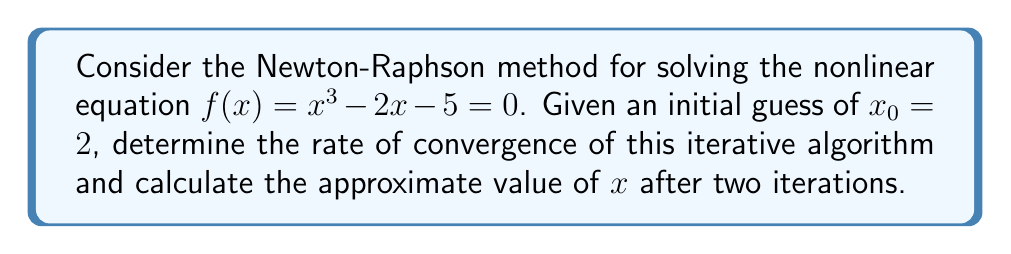What is the answer to this math problem? 1) The Newton-Raphson method is given by the iterative formula:

   $$x_{n+1} = x_n - \frac{f(x_n)}{f'(x_n)}$$

2) For our function $f(x) = x^3 - 2x - 5$, we need to calculate $f'(x)$:
   
   $$f'(x) = 3x^2 - 2$$

3) Now, let's perform the iterations:

   For $n = 0$:
   $$x_1 = 2 - \frac{f(2)}{f'(2)} = 2 - \frac{2^3 - 2(2) - 5}{3(2)^2 - 2} = 2 - \frac{-1}{10} = 2.1$$

   For $n = 1$:
   $$x_2 = 2.1 - \frac{f(2.1)}{f'(2.1)} = 2.1 - \frac{2.1^3 - 2(2.1) - 5}{3(2.1)^2 - 2} \approx 2.0946$$

4) To determine the rate of convergence, we need to look at the error term:

   $$|e_{n+1}| \approx C|e_n|^p$$

   where $C$ is a constant and $p$ is the order of convergence.

5) For the Newton-Raphson method, it's known that $p = 2$ (quadratic convergence) if $f'(x) \neq 0$ near the root and $f''(x)$ is continuous.

6) We can verify this by calculating:

   $$\frac{|x_2 - x^*|}{|x_1 - x^*|^2}$$

   where $x^*$ is the true root. We don't know $x^*$ exactly, but we can approximate it with $x_2$.

7) This ratio should be approximately constant if the convergence is indeed quadratic.
Answer: Quadratic convergence, $x_2 \approx 2.0946$ 